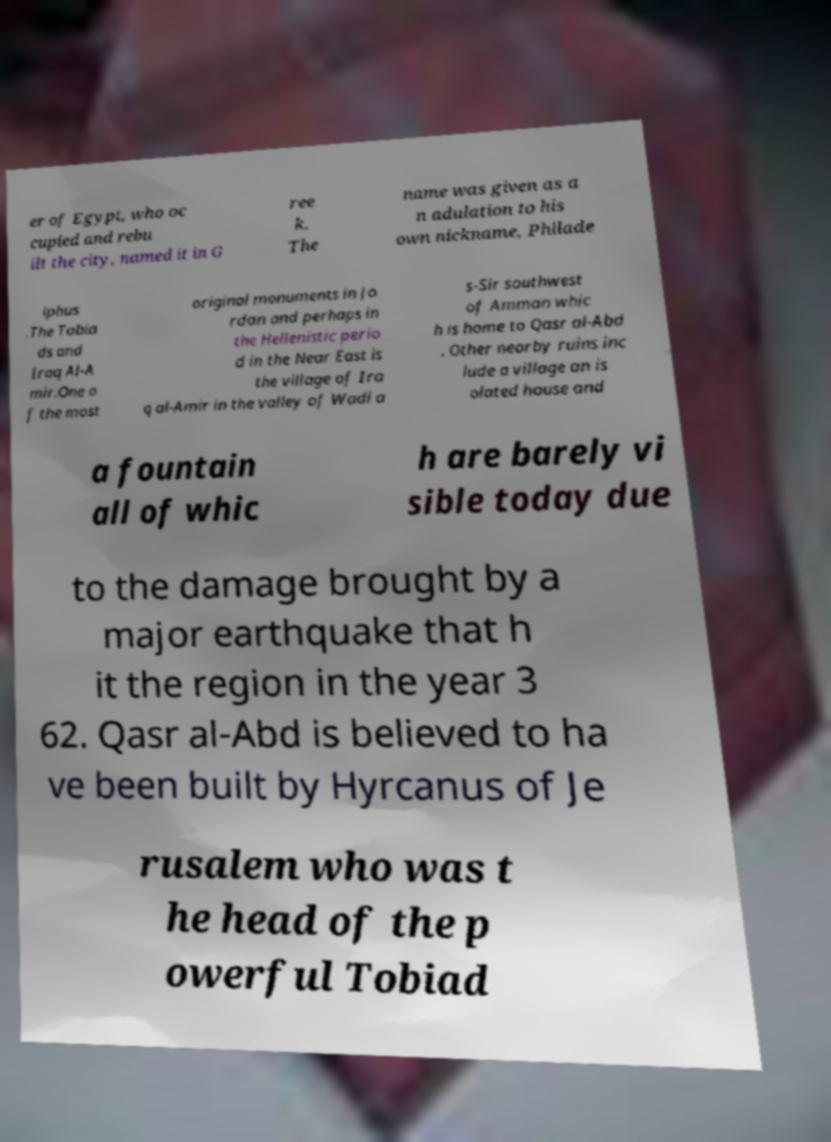Please read and relay the text visible in this image. What does it say? er of Egypt, who oc cupied and rebu ilt the city, named it in G ree k. The name was given as a n adulation to his own nickname, Philade lphus .The Tobia ds and Iraq Al-A mir.One o f the most original monuments in Jo rdan and perhaps in the Hellenistic perio d in the Near East is the village of Ira q al-Amir in the valley of Wadi a s-Sir southwest of Amman whic h is home to Qasr al-Abd . Other nearby ruins inc lude a village an is olated house and a fountain all of whic h are barely vi sible today due to the damage brought by a major earthquake that h it the region in the year 3 62. Qasr al-Abd is believed to ha ve been built by Hyrcanus of Je rusalem who was t he head of the p owerful Tobiad 